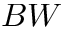<formula> <loc_0><loc_0><loc_500><loc_500>B W</formula> 